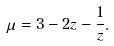Convert formula to latex. <formula><loc_0><loc_0><loc_500><loc_500>\mu = 3 - 2 z - \frac { 1 } { z } .</formula> 